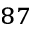<formula> <loc_0><loc_0><loc_500><loc_500>^ { 8 7 }</formula> 